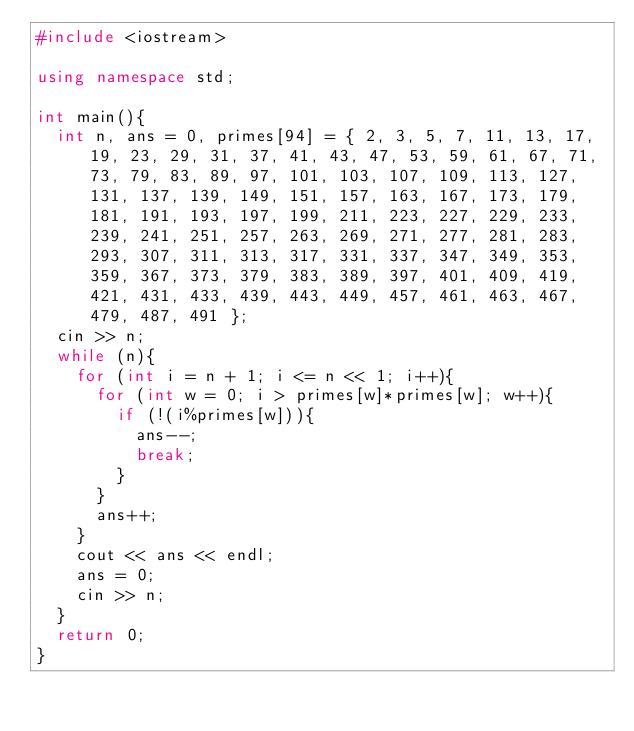Convert code to text. <code><loc_0><loc_0><loc_500><loc_500><_C++_>#include <iostream>

using namespace std;

int main(){
	int n, ans = 0, primes[94] = { 2, 3, 5, 7, 11, 13, 17, 19, 23, 29, 31, 37, 41, 43, 47, 53, 59, 61, 67, 71, 73, 79, 83, 89, 97, 101, 103, 107, 109, 113, 127, 131, 137, 139, 149, 151, 157, 163, 167, 173, 179, 181, 191, 193, 197, 199, 211, 223, 227, 229, 233, 239, 241, 251, 257, 263, 269, 271, 277, 281, 283, 293, 307, 311, 313, 317, 331, 337, 347, 349, 353, 359, 367, 373, 379, 383, 389, 397, 401, 409, 419, 421, 431, 433, 439, 443, 449, 457, 461, 463, 467, 479, 487, 491 };
	cin >> n;
	while (n){
		for (int i = n + 1; i <= n << 1; i++){
			for (int w = 0; i > primes[w]*primes[w]; w++){
				if (!(i%primes[w])){
					ans--;
					break;
				}
			}
			ans++;
		}
		cout << ans << endl;
		ans = 0;
		cin >> n;
	}
	return 0;
}</code> 